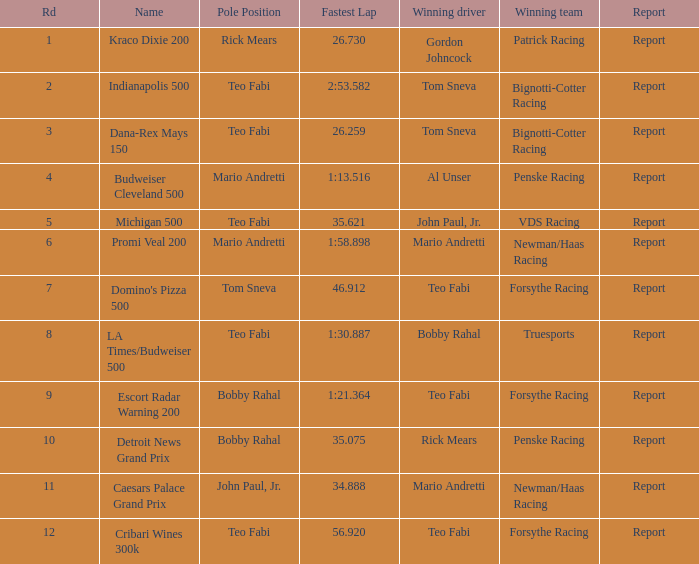Which teams emerged victorious when bobby rahal was their triumphant driver? Truesports. 